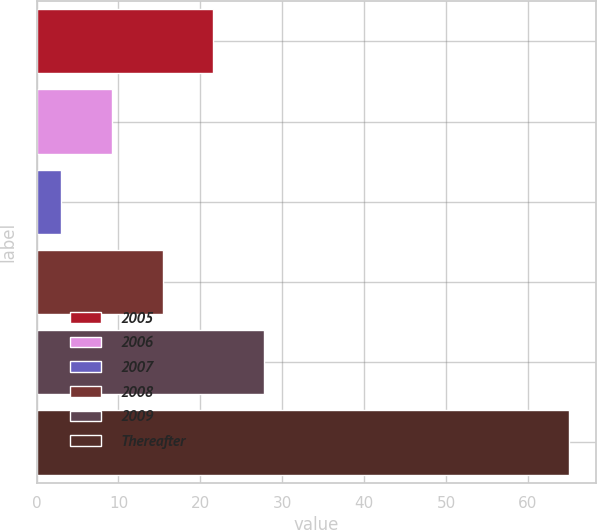Convert chart to OTSL. <chart><loc_0><loc_0><loc_500><loc_500><bar_chart><fcel>2005<fcel>2006<fcel>2007<fcel>2008<fcel>2009<fcel>Thereafter<nl><fcel>21.6<fcel>9.2<fcel>3<fcel>15.4<fcel>27.8<fcel>65<nl></chart> 